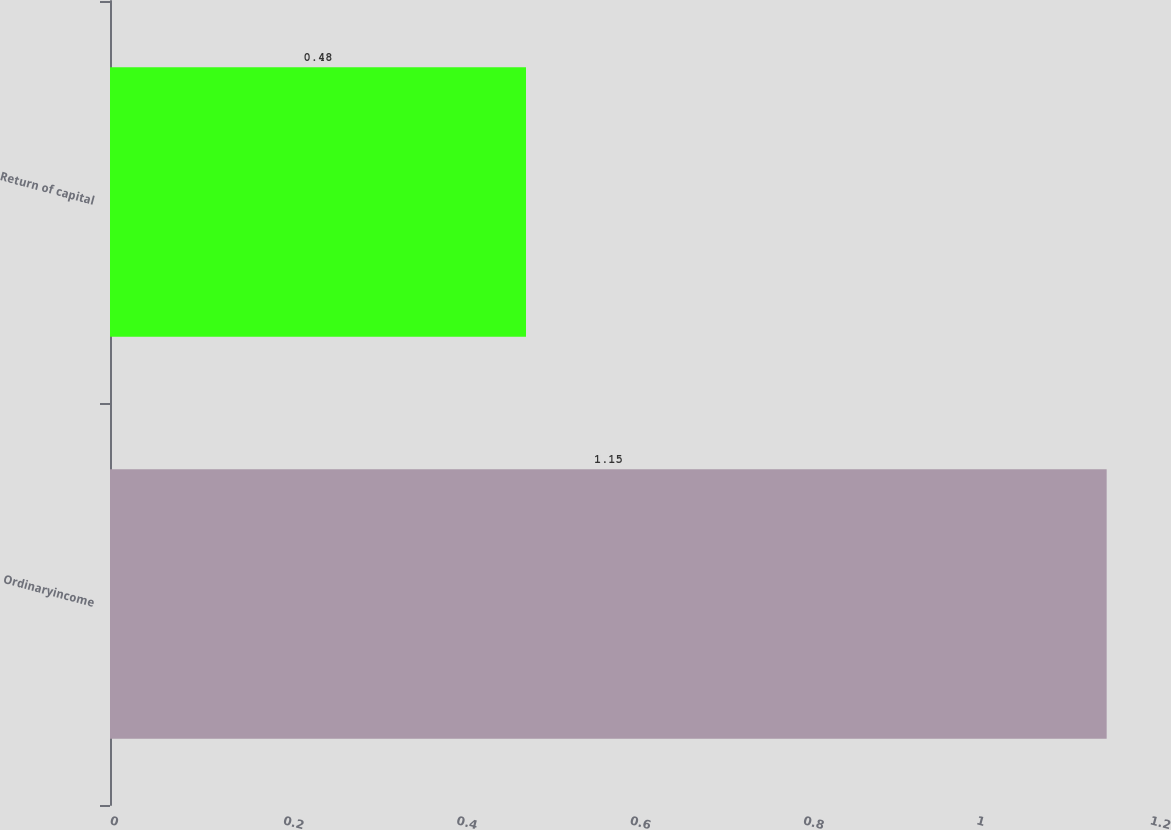<chart> <loc_0><loc_0><loc_500><loc_500><bar_chart><fcel>Ordinaryincome<fcel>Return of capital<nl><fcel>1.15<fcel>0.48<nl></chart> 